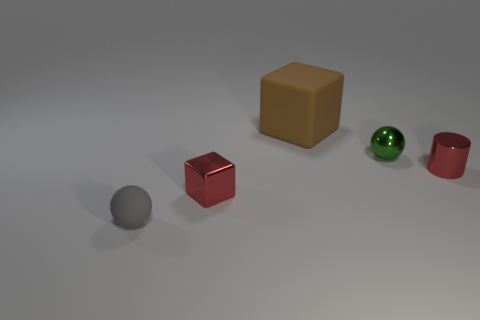Add 1 cylinders. How many objects exist? 6 Subtract all spheres. How many objects are left? 3 Add 3 large brown cubes. How many large brown cubes are left? 4 Add 3 red cylinders. How many red cylinders exist? 4 Subtract 0 green cylinders. How many objects are left? 5 Subtract all small red objects. Subtract all small green objects. How many objects are left? 2 